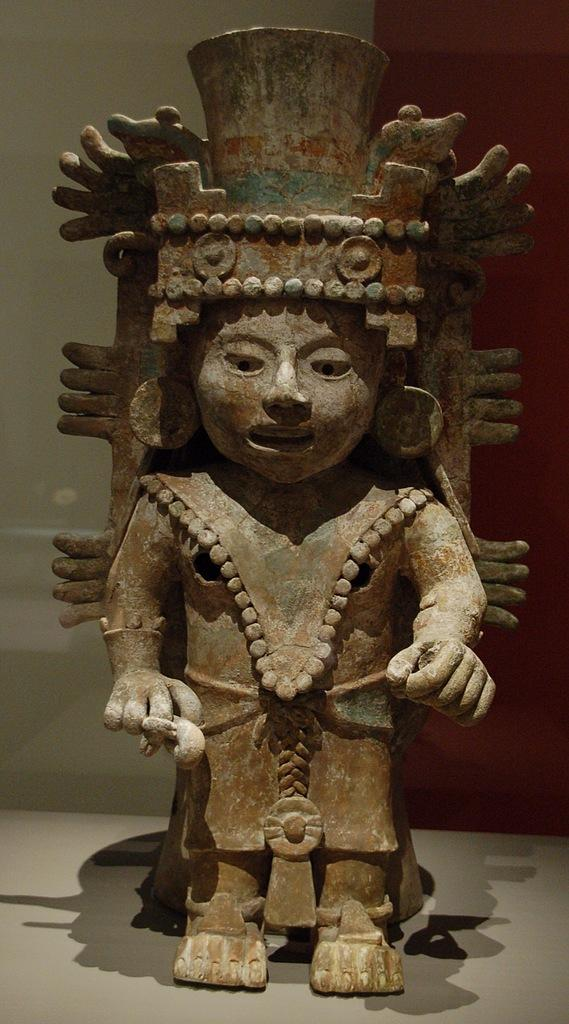What is the main subject in the center of the image? There is a statue in the center of the image. What is the surface beneath the statue? There is a floor at the bottom of the image. What can be seen behind the statue? There is a wall in the background of the image. What type of plant is growing on the statue's tongue in the image? There is no plant or tongue present on the statue in the image. 